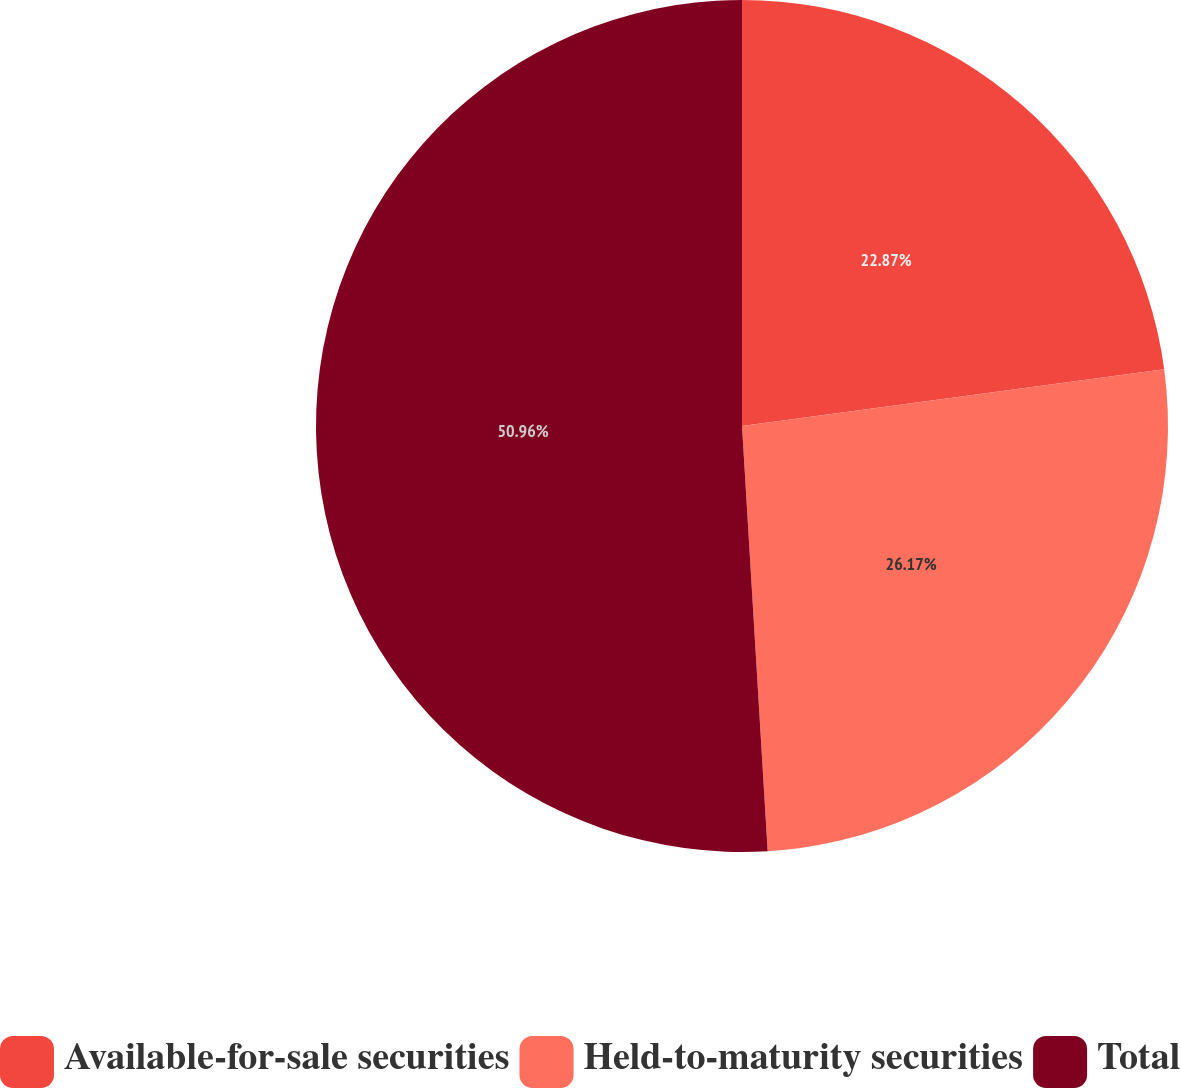Convert chart. <chart><loc_0><loc_0><loc_500><loc_500><pie_chart><fcel>Available-for-sale securities<fcel>Held-to-maturity securities<fcel>Total<nl><fcel>22.87%<fcel>26.17%<fcel>50.96%<nl></chart> 